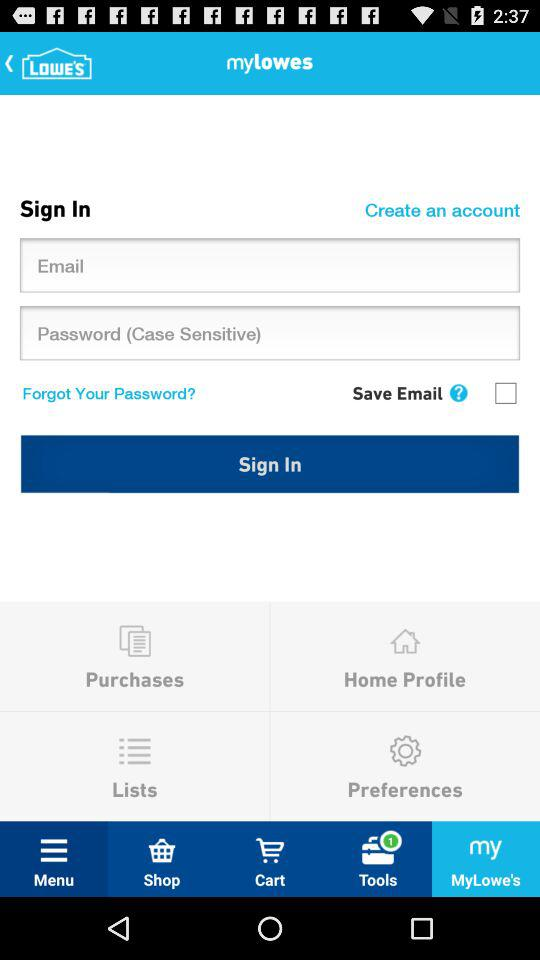Which tab has been selected? The tab "MyLowe's" has been selected. 